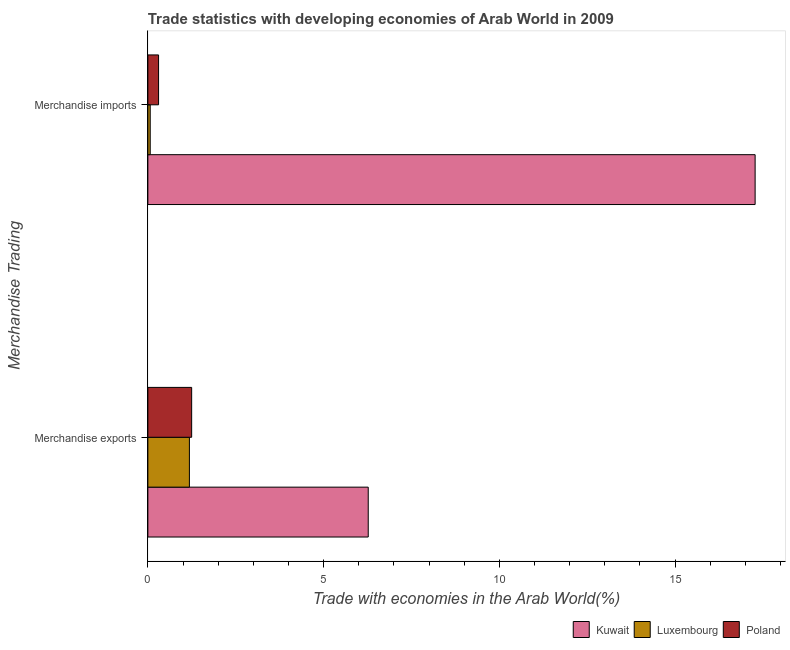Are the number of bars on each tick of the Y-axis equal?
Provide a short and direct response. Yes. What is the label of the 2nd group of bars from the top?
Provide a succinct answer. Merchandise exports. What is the merchandise imports in Luxembourg?
Offer a terse response. 0.07. Across all countries, what is the maximum merchandise exports?
Give a very brief answer. 6.27. Across all countries, what is the minimum merchandise exports?
Provide a short and direct response. 1.18. In which country was the merchandise imports maximum?
Make the answer very short. Kuwait. In which country was the merchandise exports minimum?
Make the answer very short. Luxembourg. What is the total merchandise exports in the graph?
Make the answer very short. 8.7. What is the difference between the merchandise imports in Poland and that in Luxembourg?
Provide a succinct answer. 0.24. What is the difference between the merchandise imports in Kuwait and the merchandise exports in Poland?
Your answer should be compact. 16.03. What is the average merchandise imports per country?
Provide a succinct answer. 5.88. What is the difference between the merchandise imports and merchandise exports in Poland?
Provide a short and direct response. -0.94. What is the ratio of the merchandise imports in Kuwait to that in Luxembourg?
Your answer should be compact. 257.77. In how many countries, is the merchandise exports greater than the average merchandise exports taken over all countries?
Offer a terse response. 1. What does the 2nd bar from the top in Merchandise imports represents?
Provide a short and direct response. Luxembourg. What does the 2nd bar from the bottom in Merchandise exports represents?
Your answer should be compact. Luxembourg. Are all the bars in the graph horizontal?
Your response must be concise. Yes. How many countries are there in the graph?
Provide a short and direct response. 3. What is the difference between two consecutive major ticks on the X-axis?
Provide a succinct answer. 5. Where does the legend appear in the graph?
Provide a short and direct response. Bottom right. How many legend labels are there?
Provide a short and direct response. 3. How are the legend labels stacked?
Ensure brevity in your answer.  Horizontal. What is the title of the graph?
Give a very brief answer. Trade statistics with developing economies of Arab World in 2009. Does "Lithuania" appear as one of the legend labels in the graph?
Offer a very short reply. No. What is the label or title of the X-axis?
Your answer should be compact. Trade with economies in the Arab World(%). What is the label or title of the Y-axis?
Ensure brevity in your answer.  Merchandise Trading. What is the Trade with economies in the Arab World(%) of Kuwait in Merchandise exports?
Make the answer very short. 6.27. What is the Trade with economies in the Arab World(%) in Luxembourg in Merchandise exports?
Your response must be concise. 1.18. What is the Trade with economies in the Arab World(%) of Poland in Merchandise exports?
Offer a terse response. 1.25. What is the Trade with economies in the Arab World(%) of Kuwait in Merchandise imports?
Your response must be concise. 17.28. What is the Trade with economies in the Arab World(%) of Luxembourg in Merchandise imports?
Your answer should be compact. 0.07. What is the Trade with economies in the Arab World(%) of Poland in Merchandise imports?
Give a very brief answer. 0.3. Across all Merchandise Trading, what is the maximum Trade with economies in the Arab World(%) in Kuwait?
Provide a succinct answer. 17.28. Across all Merchandise Trading, what is the maximum Trade with economies in the Arab World(%) in Luxembourg?
Provide a short and direct response. 1.18. Across all Merchandise Trading, what is the maximum Trade with economies in the Arab World(%) in Poland?
Ensure brevity in your answer.  1.25. Across all Merchandise Trading, what is the minimum Trade with economies in the Arab World(%) in Kuwait?
Give a very brief answer. 6.27. Across all Merchandise Trading, what is the minimum Trade with economies in the Arab World(%) of Luxembourg?
Offer a very short reply. 0.07. Across all Merchandise Trading, what is the minimum Trade with economies in the Arab World(%) in Poland?
Provide a succinct answer. 0.3. What is the total Trade with economies in the Arab World(%) in Kuwait in the graph?
Make the answer very short. 23.55. What is the total Trade with economies in the Arab World(%) in Luxembourg in the graph?
Provide a succinct answer. 1.25. What is the total Trade with economies in the Arab World(%) of Poland in the graph?
Your answer should be compact. 1.55. What is the difference between the Trade with economies in the Arab World(%) of Kuwait in Merchandise exports and that in Merchandise imports?
Make the answer very short. -11.01. What is the difference between the Trade with economies in the Arab World(%) in Luxembourg in Merchandise exports and that in Merchandise imports?
Your response must be concise. 1.11. What is the difference between the Trade with economies in the Arab World(%) of Poland in Merchandise exports and that in Merchandise imports?
Your response must be concise. 0.94. What is the difference between the Trade with economies in the Arab World(%) in Kuwait in Merchandise exports and the Trade with economies in the Arab World(%) in Luxembourg in Merchandise imports?
Give a very brief answer. 6.2. What is the difference between the Trade with economies in the Arab World(%) of Kuwait in Merchandise exports and the Trade with economies in the Arab World(%) of Poland in Merchandise imports?
Provide a short and direct response. 5.96. What is the difference between the Trade with economies in the Arab World(%) of Luxembourg in Merchandise exports and the Trade with economies in the Arab World(%) of Poland in Merchandise imports?
Provide a succinct answer. 0.88. What is the average Trade with economies in the Arab World(%) of Kuwait per Merchandise Trading?
Your answer should be compact. 11.77. What is the average Trade with economies in the Arab World(%) of Luxembourg per Merchandise Trading?
Offer a terse response. 0.62. What is the average Trade with economies in the Arab World(%) in Poland per Merchandise Trading?
Your response must be concise. 0.78. What is the difference between the Trade with economies in the Arab World(%) in Kuwait and Trade with economies in the Arab World(%) in Luxembourg in Merchandise exports?
Provide a succinct answer. 5.09. What is the difference between the Trade with economies in the Arab World(%) in Kuwait and Trade with economies in the Arab World(%) in Poland in Merchandise exports?
Offer a very short reply. 5.02. What is the difference between the Trade with economies in the Arab World(%) of Luxembourg and Trade with economies in the Arab World(%) of Poland in Merchandise exports?
Ensure brevity in your answer.  -0.06. What is the difference between the Trade with economies in the Arab World(%) of Kuwait and Trade with economies in the Arab World(%) of Luxembourg in Merchandise imports?
Provide a short and direct response. 17.21. What is the difference between the Trade with economies in the Arab World(%) of Kuwait and Trade with economies in the Arab World(%) of Poland in Merchandise imports?
Offer a very short reply. 16.97. What is the difference between the Trade with economies in the Arab World(%) of Luxembourg and Trade with economies in the Arab World(%) of Poland in Merchandise imports?
Provide a succinct answer. -0.24. What is the ratio of the Trade with economies in the Arab World(%) of Kuwait in Merchandise exports to that in Merchandise imports?
Your response must be concise. 0.36. What is the ratio of the Trade with economies in the Arab World(%) in Luxembourg in Merchandise exports to that in Merchandise imports?
Keep it short and to the point. 17.63. What is the ratio of the Trade with economies in the Arab World(%) of Poland in Merchandise exports to that in Merchandise imports?
Keep it short and to the point. 4.09. What is the difference between the highest and the second highest Trade with economies in the Arab World(%) in Kuwait?
Provide a short and direct response. 11.01. What is the difference between the highest and the second highest Trade with economies in the Arab World(%) in Luxembourg?
Keep it short and to the point. 1.11. What is the difference between the highest and the lowest Trade with economies in the Arab World(%) of Kuwait?
Offer a very short reply. 11.01. What is the difference between the highest and the lowest Trade with economies in the Arab World(%) of Luxembourg?
Offer a very short reply. 1.11. 